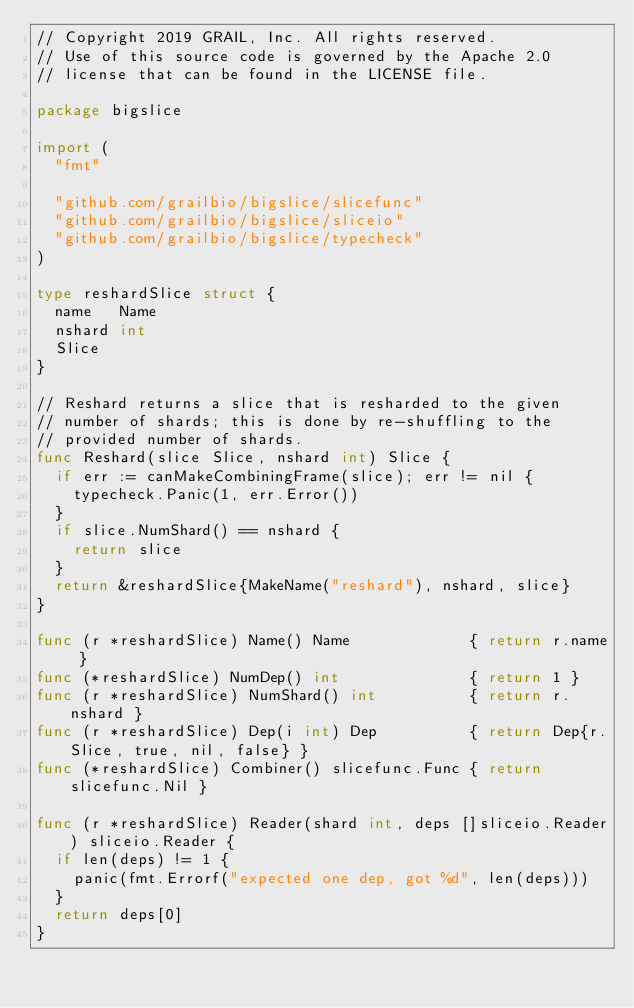Convert code to text. <code><loc_0><loc_0><loc_500><loc_500><_Go_>// Copyright 2019 GRAIL, Inc. All rights reserved.
// Use of this source code is governed by the Apache 2.0
// license that can be found in the LICENSE file.

package bigslice

import (
	"fmt"

	"github.com/grailbio/bigslice/slicefunc"
	"github.com/grailbio/bigslice/sliceio"
	"github.com/grailbio/bigslice/typecheck"
)

type reshardSlice struct {
	name   Name
	nshard int
	Slice
}

// Reshard returns a slice that is resharded to the given
// number of shards; this is done by re-shuffling to the
// provided number of shards.
func Reshard(slice Slice, nshard int) Slice {
	if err := canMakeCombiningFrame(slice); err != nil {
		typecheck.Panic(1, err.Error())
	}
	if slice.NumShard() == nshard {
		return slice
	}
	return &reshardSlice{MakeName("reshard"), nshard, slice}
}

func (r *reshardSlice) Name() Name             { return r.name }
func (*reshardSlice) NumDep() int              { return 1 }
func (r *reshardSlice) NumShard() int          { return r.nshard }
func (r *reshardSlice) Dep(i int) Dep          { return Dep{r.Slice, true, nil, false} }
func (*reshardSlice) Combiner() slicefunc.Func { return slicefunc.Nil }

func (r *reshardSlice) Reader(shard int, deps []sliceio.Reader) sliceio.Reader {
	if len(deps) != 1 {
		panic(fmt.Errorf("expected one dep, got %d", len(deps)))
	}
	return deps[0]
}
</code> 